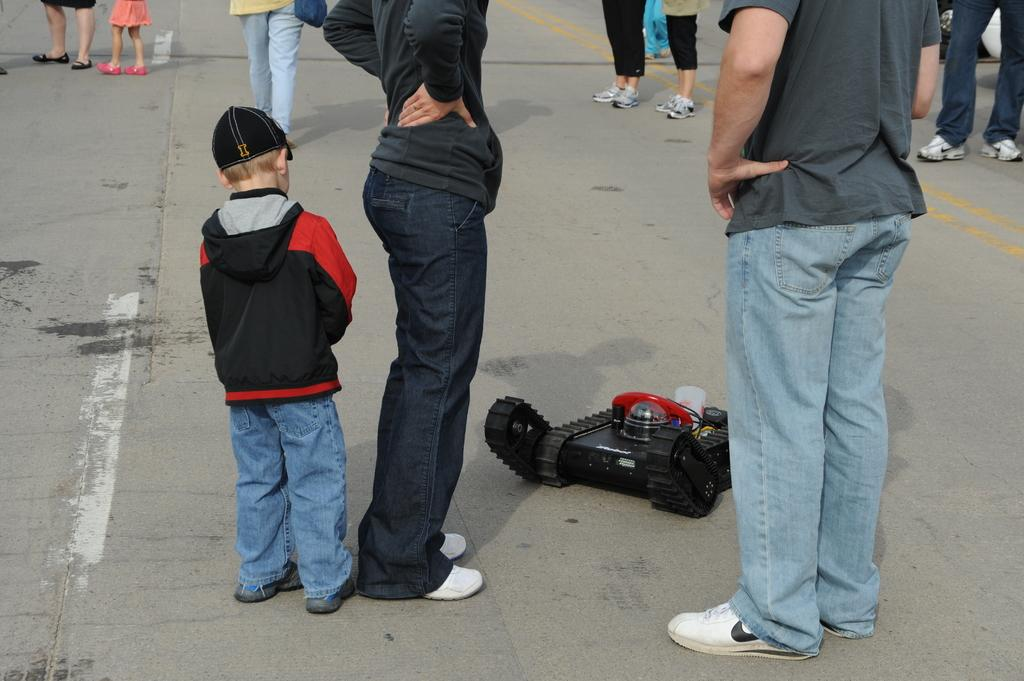Who or what can be seen in the image? There are people in the image. What else is present in the image besides the people? There is a toy vehicle on the road in the image. What type of door can be seen on the toy vehicle in the image? There is no door present on the toy vehicle in the image, as it is a toy and not a real vehicle. 